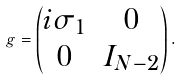Convert formula to latex. <formula><loc_0><loc_0><loc_500><loc_500>g = \begin{pmatrix} i \sigma _ { 1 } & 0 \\ 0 & I _ { N - 2 } \end{pmatrix} .</formula> 